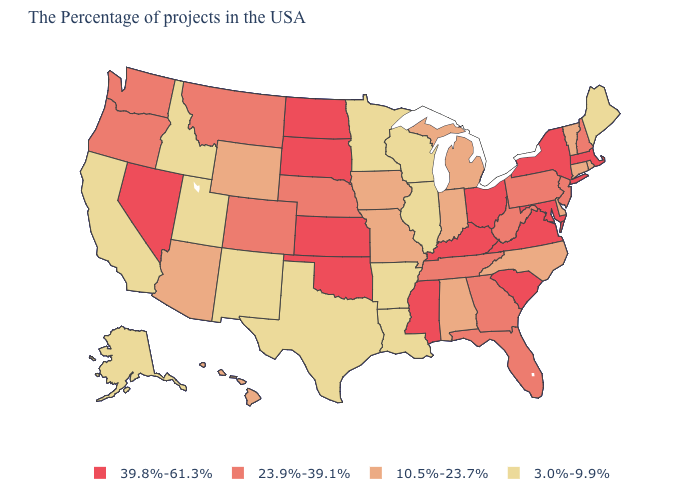Name the states that have a value in the range 3.0%-9.9%?
Quick response, please. Maine, Wisconsin, Illinois, Louisiana, Arkansas, Minnesota, Texas, New Mexico, Utah, Idaho, California, Alaska. What is the value of Ohio?
Short answer required. 39.8%-61.3%. What is the value of Arizona?
Answer briefly. 10.5%-23.7%. What is the value of Nevada?
Be succinct. 39.8%-61.3%. What is the value of California?
Short answer required. 3.0%-9.9%. Which states hav the highest value in the MidWest?
Quick response, please. Ohio, Kansas, South Dakota, North Dakota. What is the highest value in states that border Ohio?
Concise answer only. 39.8%-61.3%. What is the value of Oregon?
Keep it brief. 23.9%-39.1%. What is the highest value in states that border New York?
Write a very short answer. 39.8%-61.3%. What is the value of North Dakota?
Answer briefly. 39.8%-61.3%. Name the states that have a value in the range 3.0%-9.9%?
Quick response, please. Maine, Wisconsin, Illinois, Louisiana, Arkansas, Minnesota, Texas, New Mexico, Utah, Idaho, California, Alaska. Does Wisconsin have the lowest value in the MidWest?
Be succinct. Yes. How many symbols are there in the legend?
Be succinct. 4. 